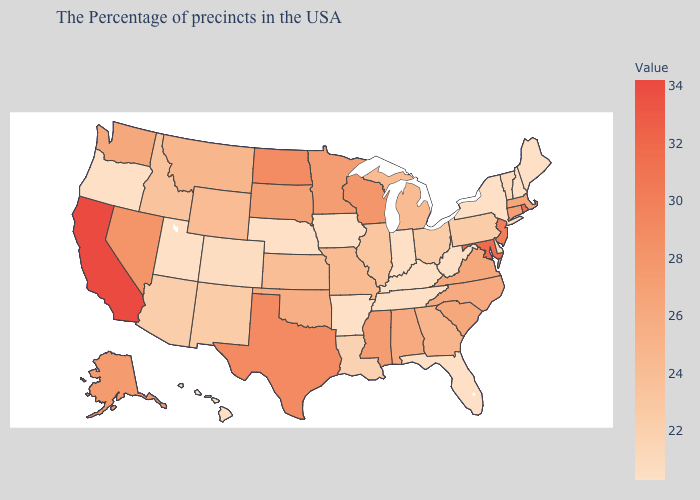Is the legend a continuous bar?
Be succinct. Yes. Which states have the lowest value in the Northeast?
Quick response, please. Maine, New Hampshire, New York. Does Oklahoma have a higher value than Kansas?
Give a very brief answer. Yes. Is the legend a continuous bar?
Answer briefly. Yes. 